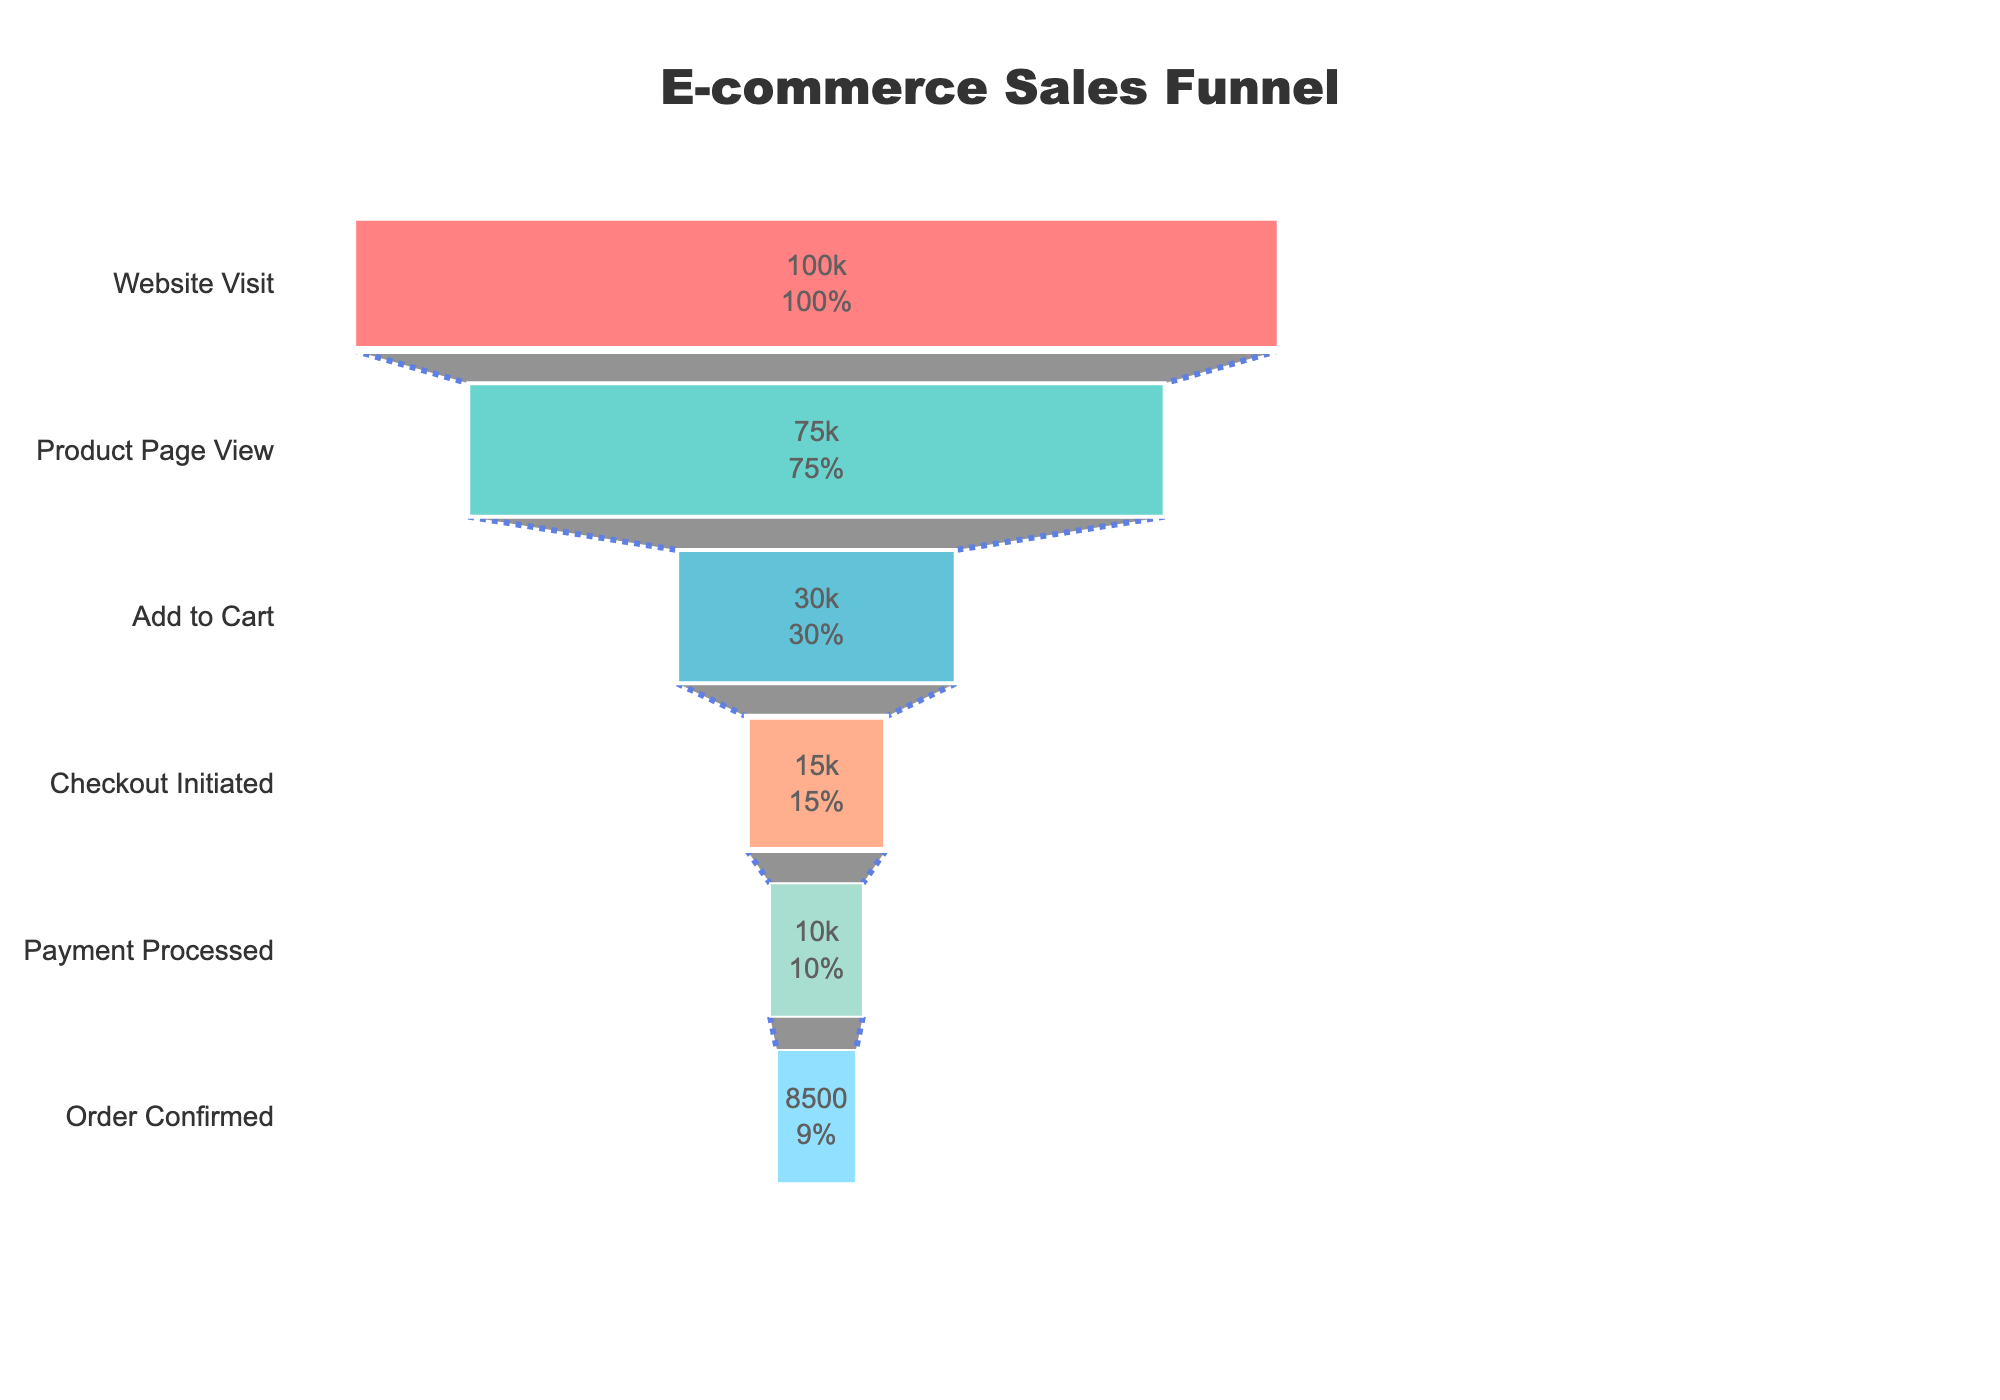What's the title of the figure? The title is located at the top of the figure. It is typically descriptive of the data being visualized.
Answer: E-commerce Sales Funnel What is the initial number of visitors at the "Website Visit" stage? The "Website Visit" stage is the starting point of the funnel. The number of visitors here is visually represented at the top of the funnel.
Answer: 100,000 How many stages are there in the funnel? Count the number of distinct stages listed along the y-axis of the funnel chart.
Answer: 6 By how much do the visitors decrease from "Product Page View" to "Add to Cart"? Subtract the number of visitors in the "Add to Cart" stage from the "Product Page View" stage. 75,000 - 30,000 = 45,000
Answer: 45,000 What percentage of visitors progress from "Add to Cart" to "Order Confirmed"? First, calculate the number of visitors who progressed to "Order Confirmed" from "Add to Cart". Then, compute the percentage: (8,500 / 30,000) * 100%.
Answer: 28.33% Which stage has the highest visitor drop-off in terms of absolute numbers? Calculate the difference in visitors between consecutive stages and identify the largest difference.
Answer: Product Page View to Add to Cart What is the percentage reduction in visitors from "Checkout Initiated" to "Order Confirmed"? Subtract the number of visitors at "Order Confirmed" from "Checkout Initiated" and divide by the visitors in "Checkout Initiated". Multiply by 100 to get the percentage. ((15,000-8,500) / 15,000) * 100%.
Answer: 43.33% Compare the number of visitors in the "Product Page View" and "Payment Processed" stages. How many more visitors are there in "Product Page View"? Subtract the number of visitors in "Payment Processed" from "Product Page View". 75,000 - 10,000 = 65,000
Answer: 65,000 What is the ratio of visitors at the "Add to Cart" stage to the "Website Visit" stage? Divide the number of visitors at "Add to Cart" by the number of visitors at "Website Visit". 30,000 / 100,000 = 0.3
Answer: 0.3 